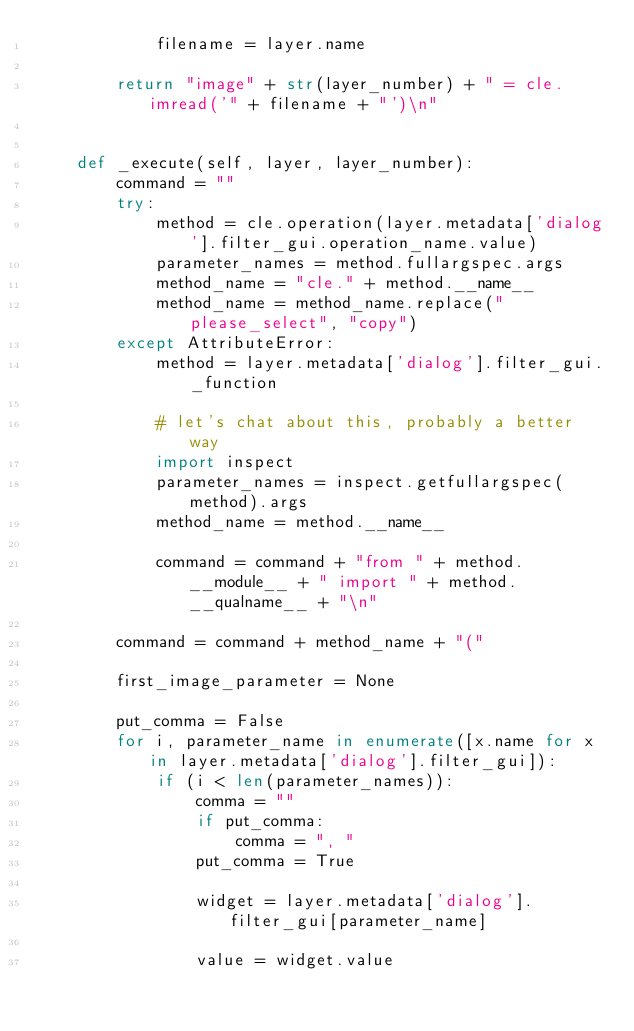Convert code to text. <code><loc_0><loc_0><loc_500><loc_500><_Python_>            filename = layer.name

        return "image" + str(layer_number) + " = cle.imread('" + filename + "')\n"


    def _execute(self, layer, layer_number):
        command = ""
        try:
            method = cle.operation(layer.metadata['dialog'].filter_gui.operation_name.value)
            parameter_names = method.fullargspec.args
            method_name = "cle." + method.__name__
            method_name = method_name.replace("please_select", "copy")
        except AttributeError:
            method = layer.metadata['dialog'].filter_gui._function

            # let's chat about this, probably a better way
            import inspect
            parameter_names = inspect.getfullargspec(method).args
            method_name = method.__name__

            command = command + "from " + method.__module__ + " import " + method.__qualname__ + "\n"

        command = command + method_name + "("

        first_image_parameter = None

        put_comma = False
        for i, parameter_name in enumerate([x.name for x in layer.metadata['dialog'].filter_gui]):
            if (i < len(parameter_names)):
                comma = ""
                if put_comma:
                    comma = ", "
                put_comma = True

                widget = layer.metadata['dialog'].filter_gui[parameter_name]

                value = widget.value
</code> 